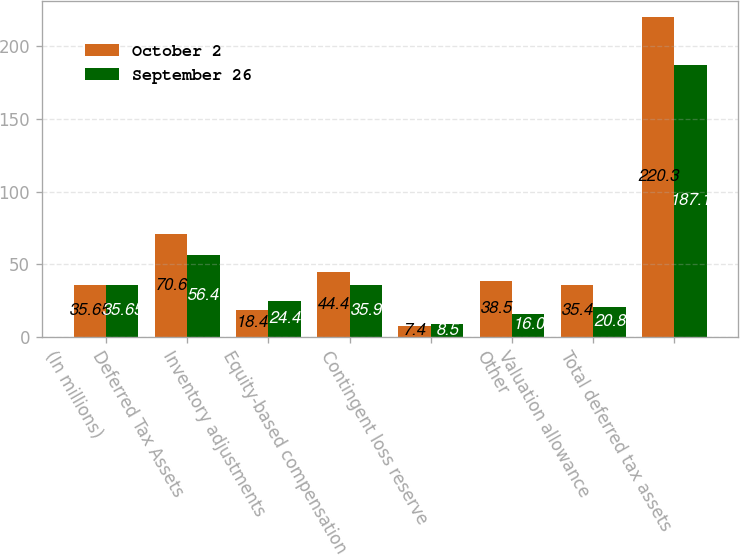Convert chart. <chart><loc_0><loc_0><loc_500><loc_500><stacked_bar_chart><ecel><fcel>(In millions)<fcel>Deferred Tax Assets<fcel>Inventory adjustments<fcel>Equity-based compensation<fcel>Contingent loss reserve<fcel>Other<fcel>Valuation allowance<fcel>Total deferred tax assets<nl><fcel>October 2<fcel>35.65<fcel>70.6<fcel>18.4<fcel>44.4<fcel>7.4<fcel>38.5<fcel>35.4<fcel>220.3<nl><fcel>September 26<fcel>35.65<fcel>56.4<fcel>24.4<fcel>35.9<fcel>8.5<fcel>16<fcel>20.8<fcel>187.1<nl></chart> 